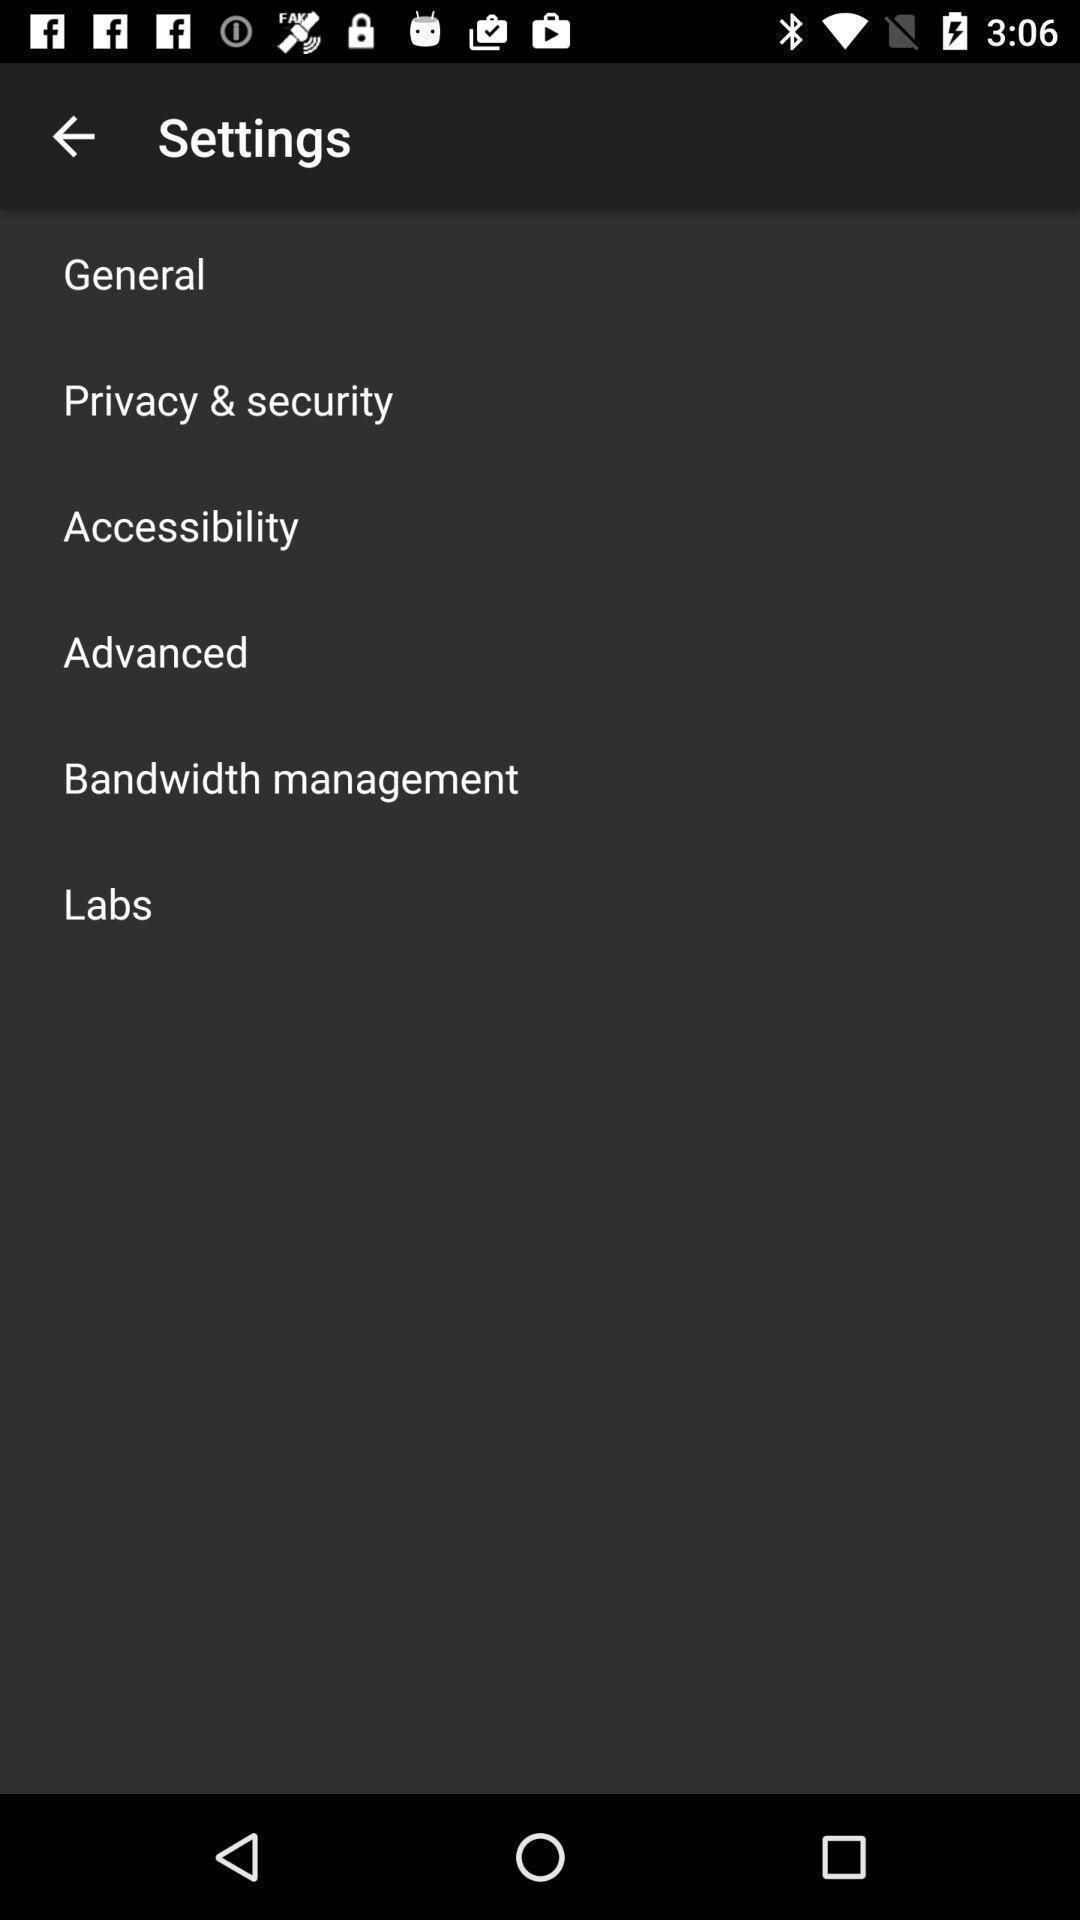What is the overall content of this screenshot? Page displays various settings in app. 